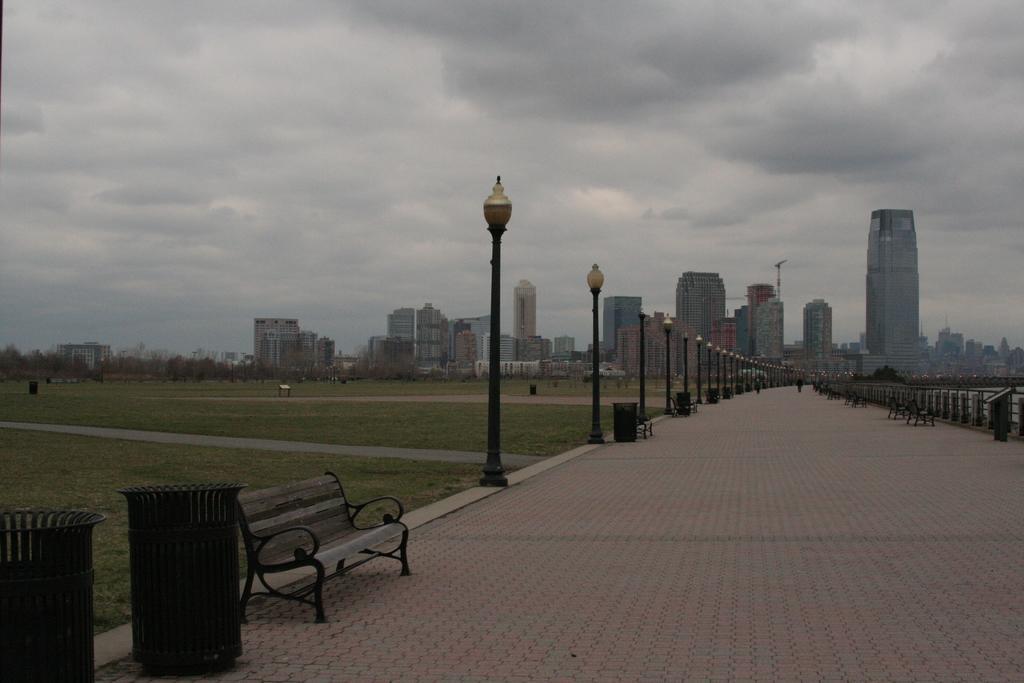Could you give a brief overview of what you see in this image? In this image we can see road. On both sides of the road benches, dustbin and pillars are there. Background of the image buildings are there. The sky is full of cloud. Left side of the image grassy land is present. 